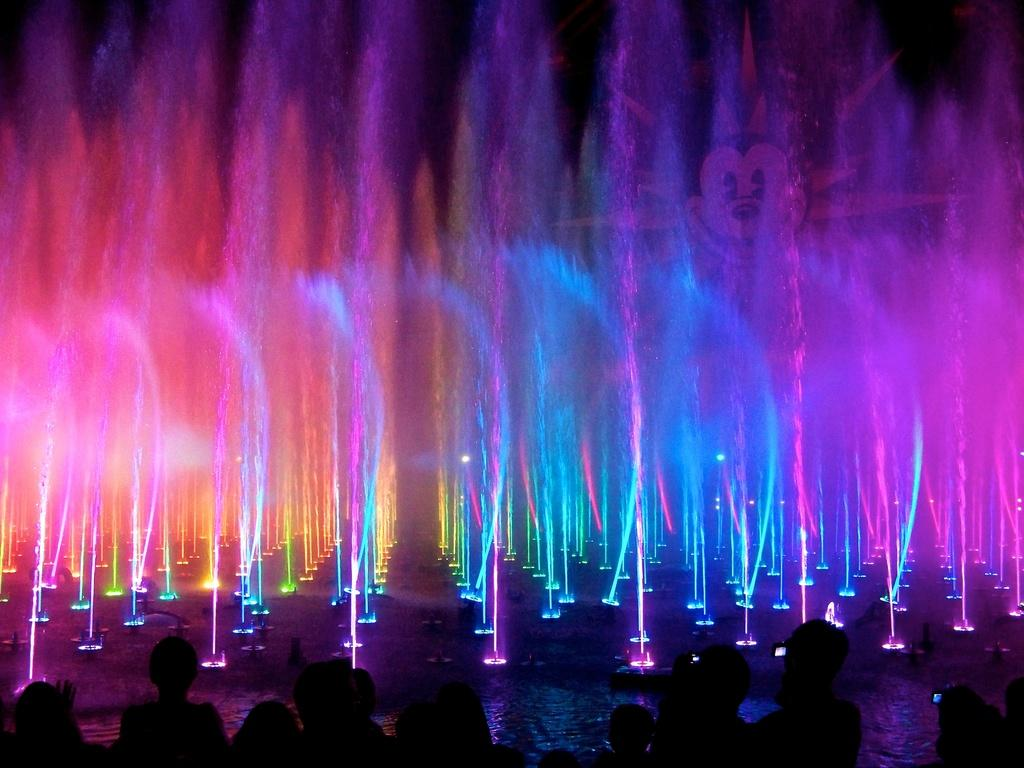What is happening in the image? There is a light show in the image, and water fountains are present. Can you describe the setting of the image? There are people at the bottom of the image, and a Mickey Mouse figure is visible. What might be the purpose of the water fountains? The water fountains might be part of the light show or a separate attraction. What type of plants are growing near the water fountains in the image? There are no plants visible in the image; it primarily features a light show and water fountains. Who is the owner of the Mickey Mouse figure in the image? The image does not provide information about the ownership of the Mickey Mouse figure. 